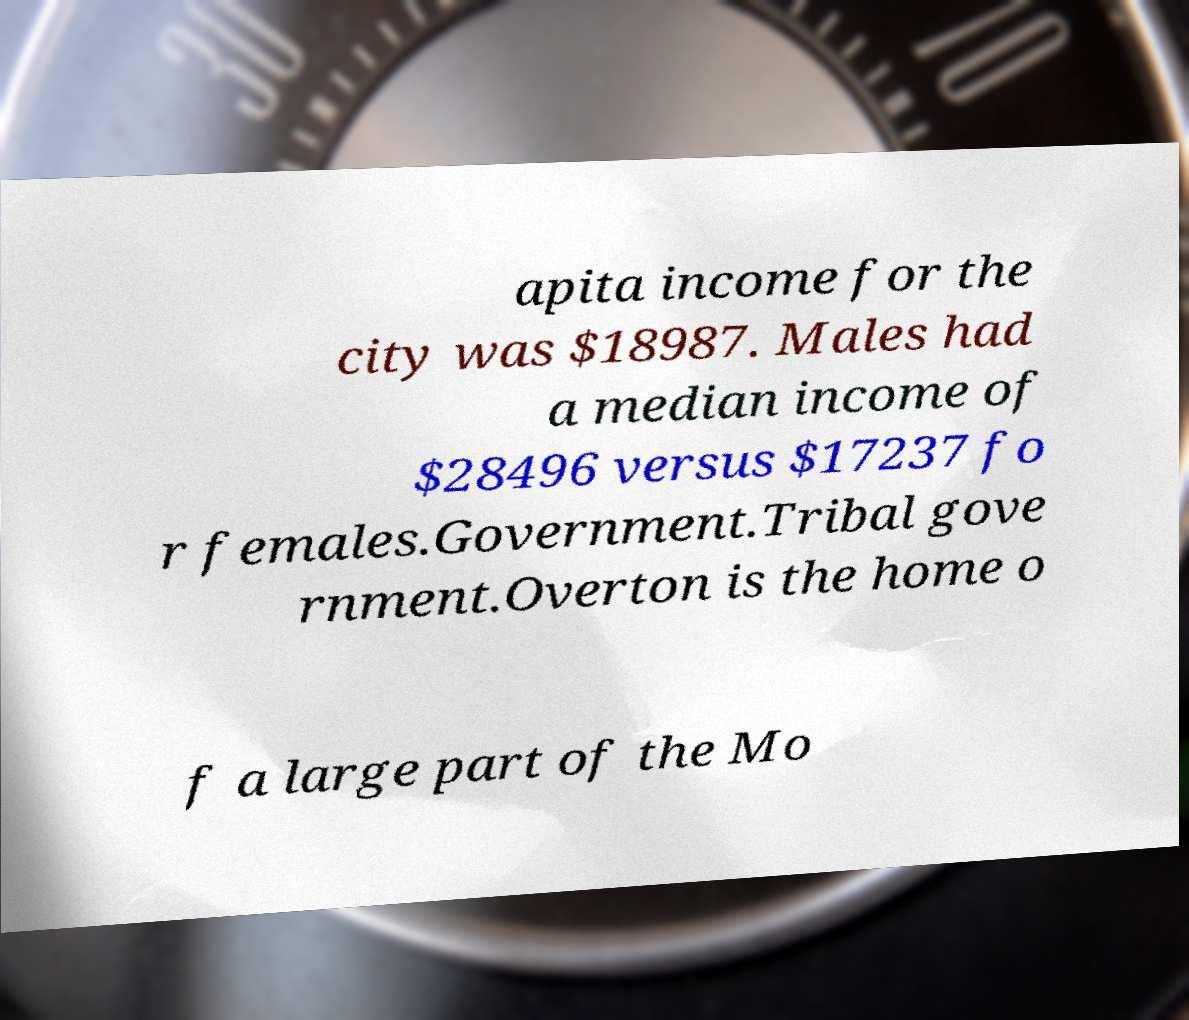Can you read and provide the text displayed in the image?This photo seems to have some interesting text. Can you extract and type it out for me? apita income for the city was $18987. Males had a median income of $28496 versus $17237 fo r females.Government.Tribal gove rnment.Overton is the home o f a large part of the Mo 